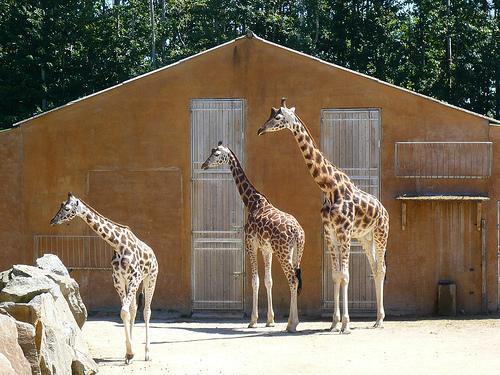How many animals are there?
Give a very brief answer. 3. 